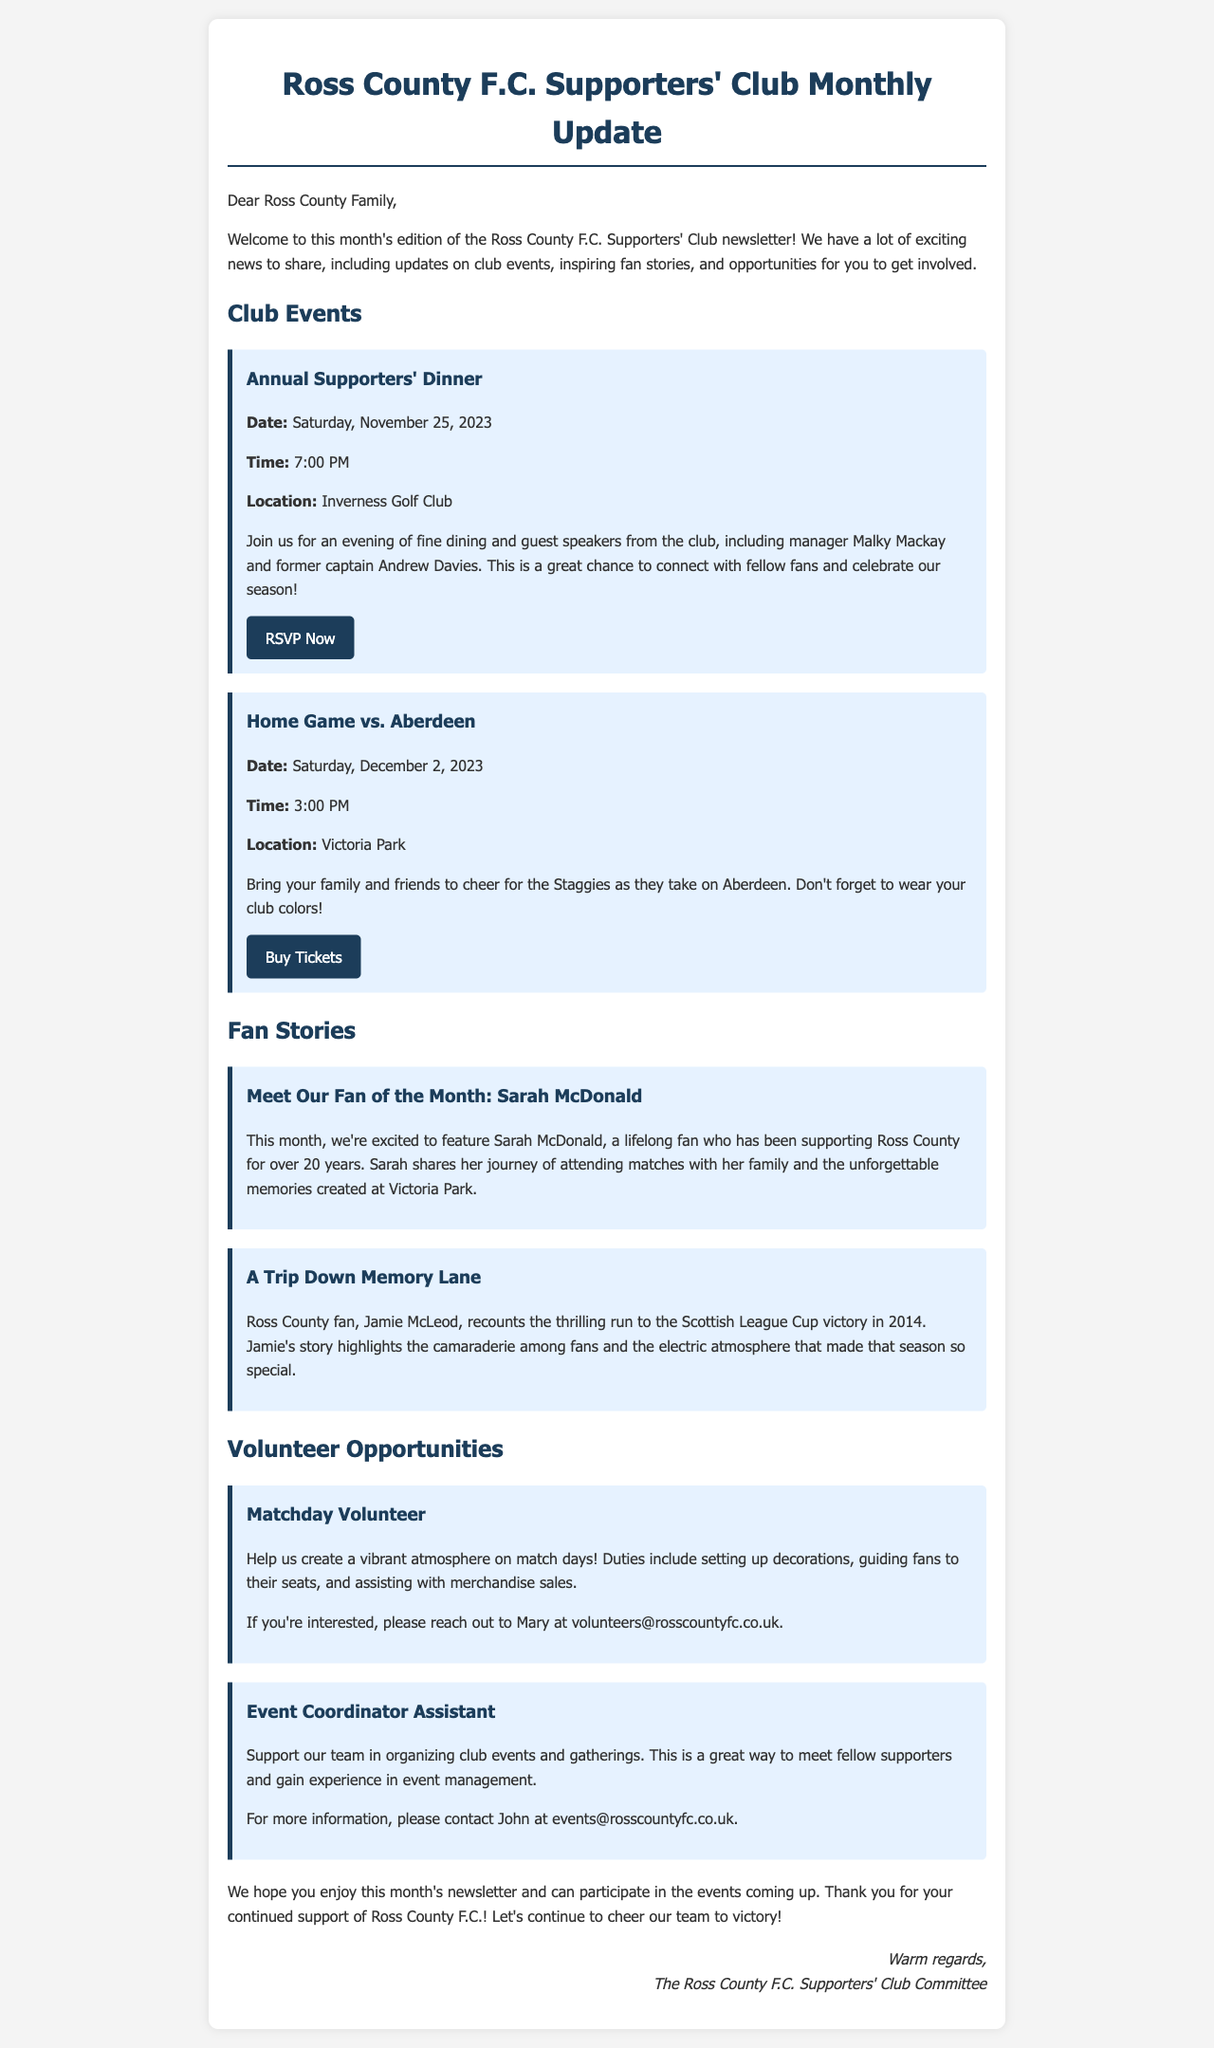What is the date of the Annual Supporters' Dinner? The date of the Annual Supporters' Dinner is mentioned in the document.
Answer: Saturday, November 25, 2023 What time does the home game vs. Aberdeen start? The document specifies the time for the home game vs. Aberdeen.
Answer: 3:00 PM Who is the Fan of the Month? The document highlights the Fan of the Month for this edition.
Answer: Sarah McDonald What is one of the duties of a Matchday Volunteer? The document lists duties for the Matchday Volunteer role.
Answer: Setting up decorations Who should be contacted for more information about the Event Coordinator Assistant role? The document provides contact information for the Event Coordinator Assistant.
Answer: John How many fan stories are featured in this newsletter? The document includes a section for fan stories, which lists the number of stories.
Answer: Two 